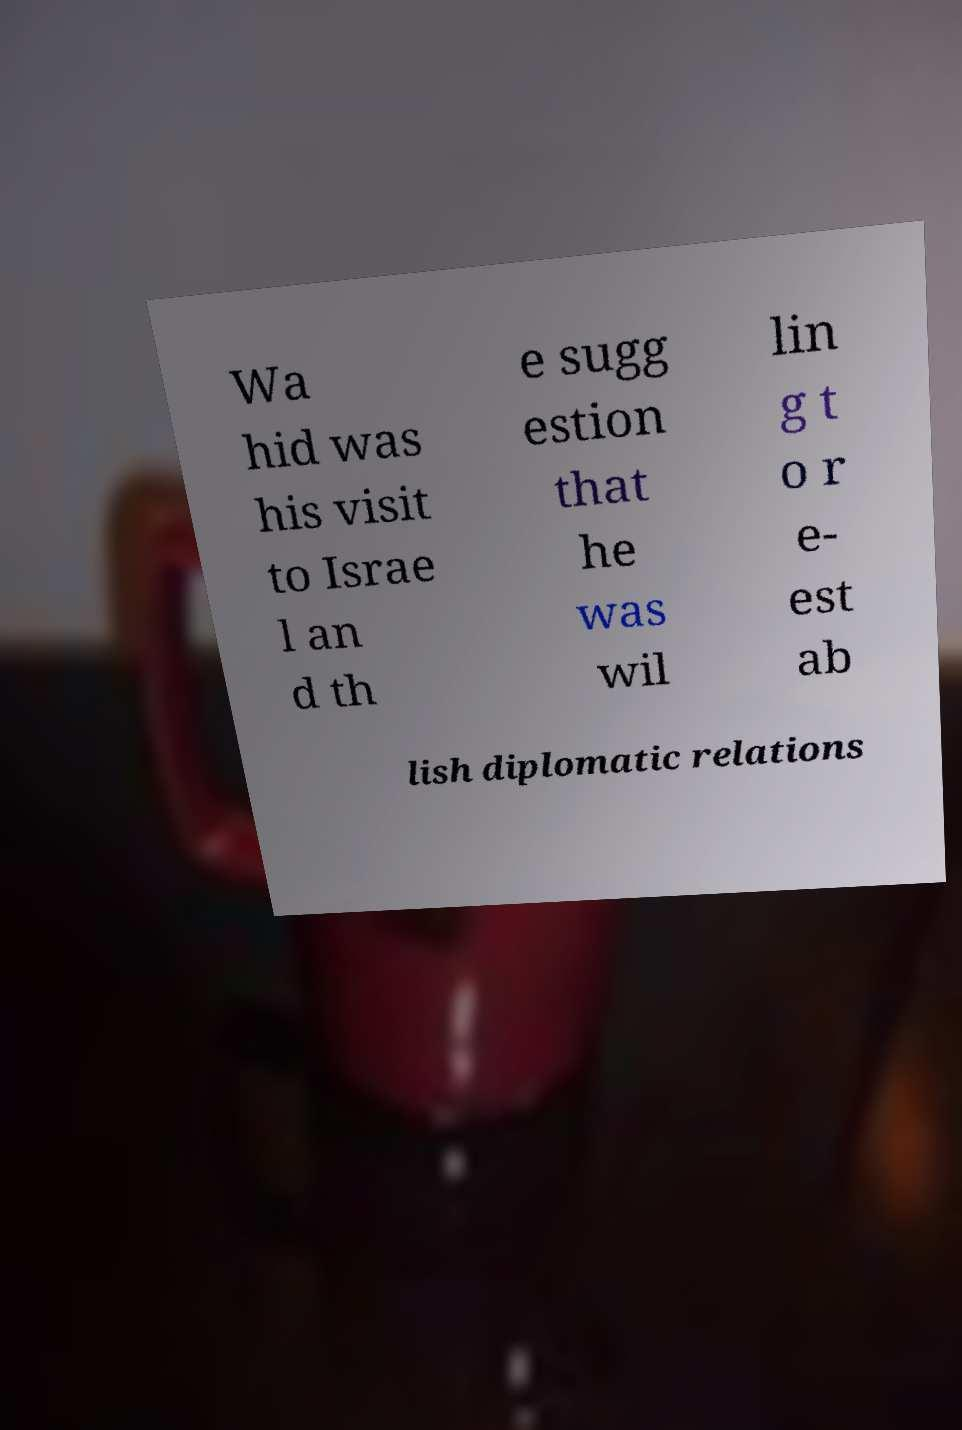Can you read and provide the text displayed in the image?This photo seems to have some interesting text. Can you extract and type it out for me? Wa hid was his visit to Israe l an d th e sugg estion that he was wil lin g t o r e- est ab lish diplomatic relations 